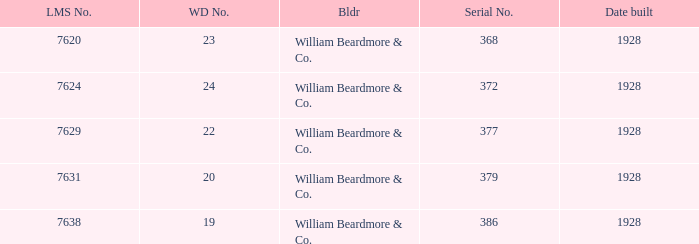Name the total number of wd number for lms number being 7638 1.0. 